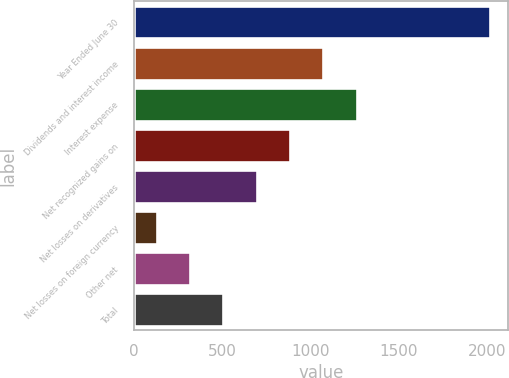Convert chart. <chart><loc_0><loc_0><loc_500><loc_500><bar_chart><fcel>Year Ended June 30<fcel>Dividends and interest income<fcel>Interest expense<fcel>Net recognized gains on<fcel>Net losses on derivatives<fcel>Net losses on foreign currency<fcel>Other net<fcel>Total<nl><fcel>2016<fcel>1072.5<fcel>1261.2<fcel>883.8<fcel>695.1<fcel>129<fcel>317.7<fcel>506.4<nl></chart> 